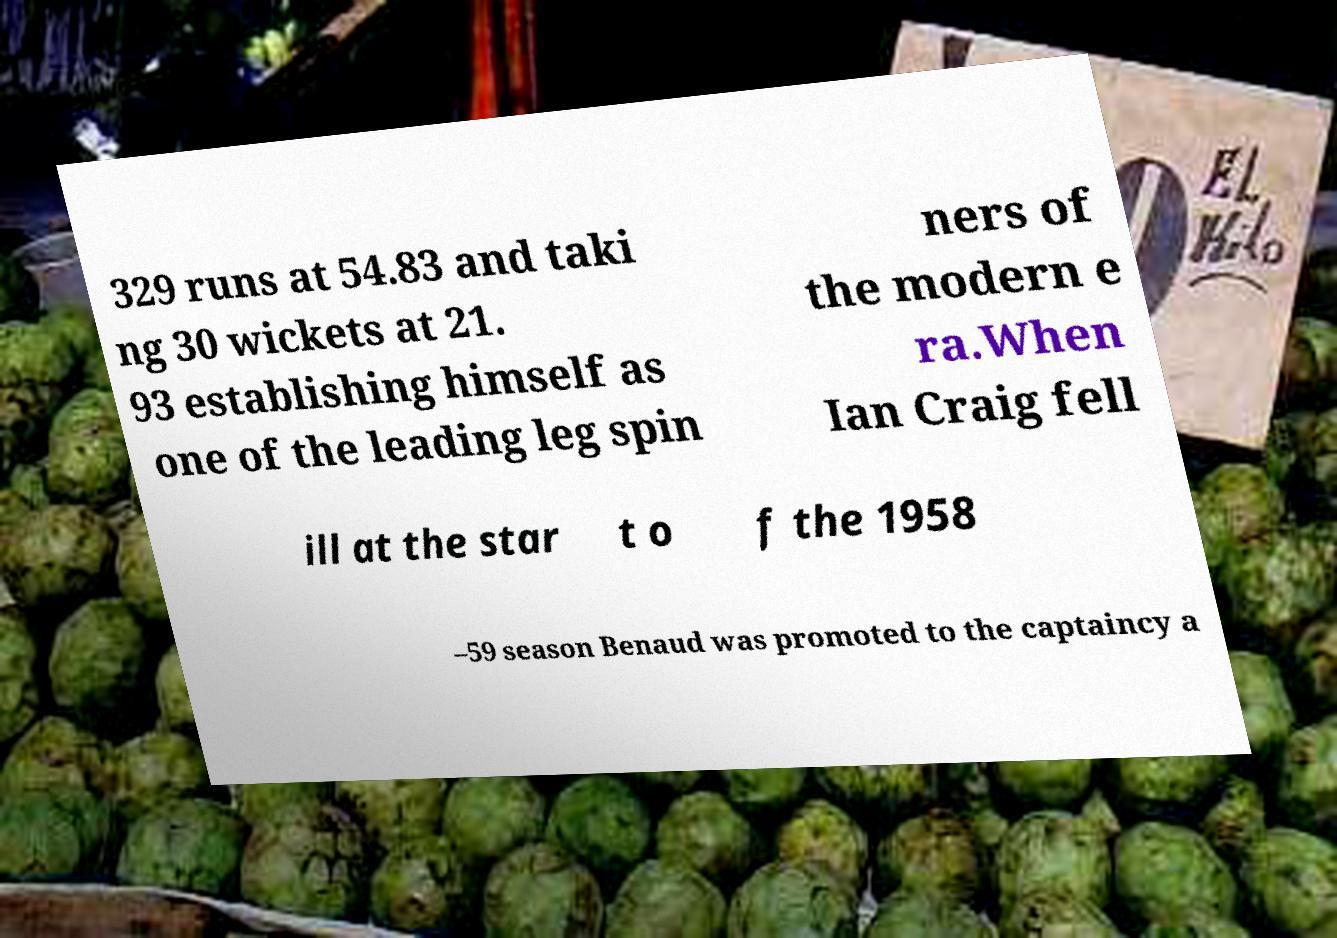Could you assist in decoding the text presented in this image and type it out clearly? 329 runs at 54.83 and taki ng 30 wickets at 21. 93 establishing himself as one of the leading leg spin ners of the modern e ra.When Ian Craig fell ill at the star t o f the 1958 –59 season Benaud was promoted to the captaincy a 